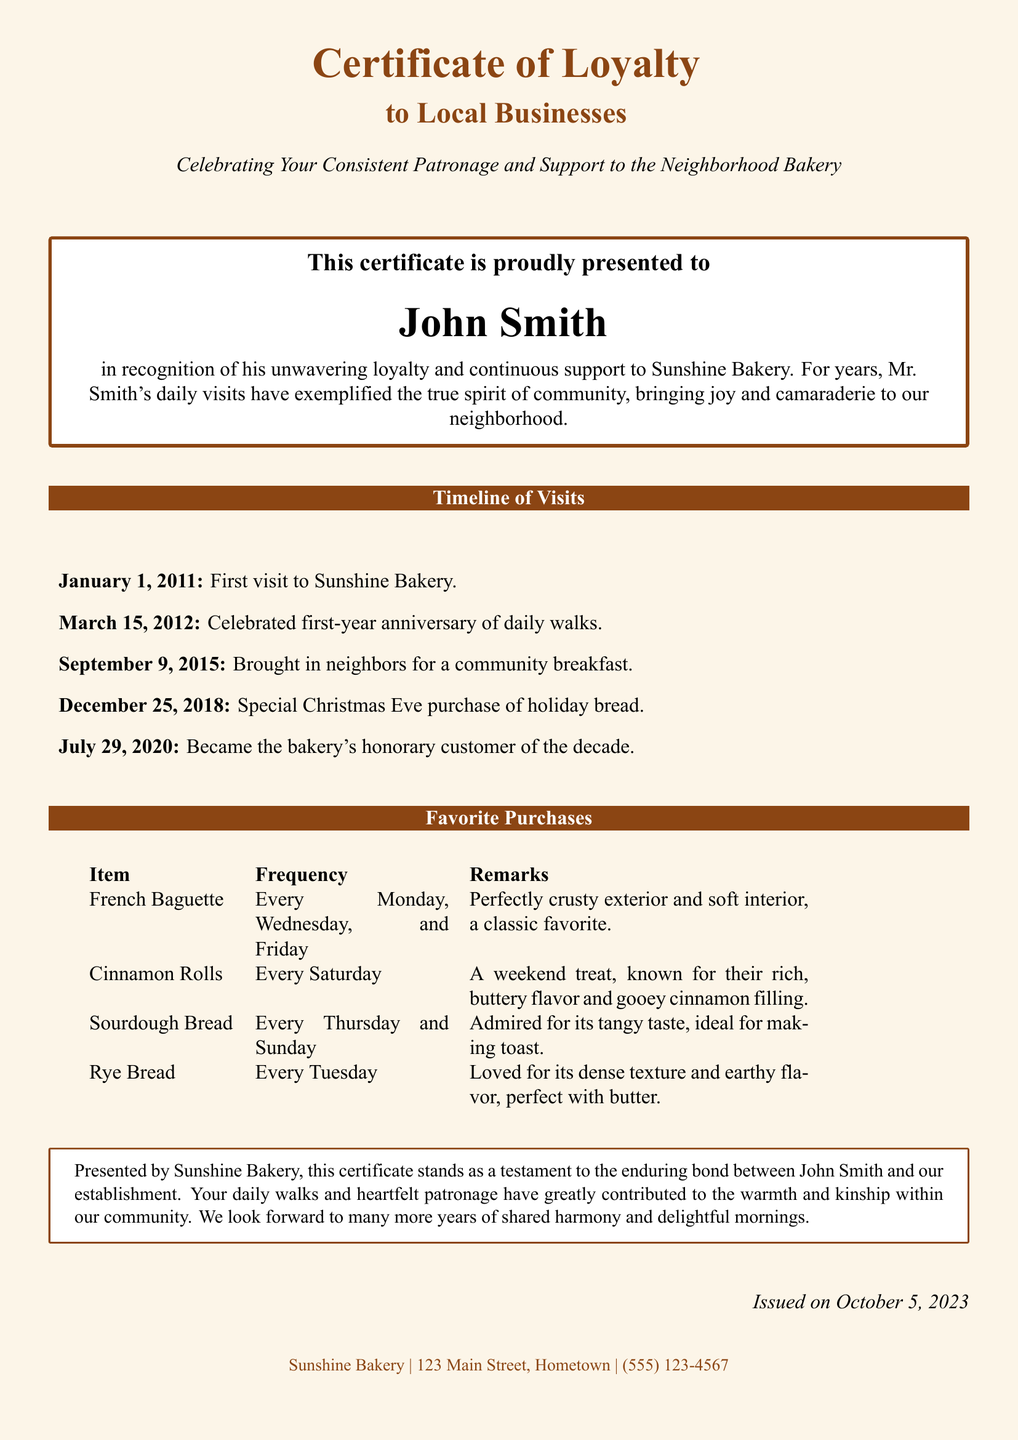What is the name of the person awarded the certificate? The name of the person awarded the certificate is stated prominently at the center of the document.
Answer: John Smith What is the name of the bakery? The bakery name is highlighted in the title of the certificate, which signifies its importance.
Answer: Sunshine Bakery When was the certificate issued? The issue date is mentioned at the bottom of the document in an italicized format.
Answer: October 5, 2023 How many favorite purchases are listed? The number of entries in the "Favorite Purchases" section indicates the available options.
Answer: Four What item is purchased every Tuesday? The "Favorite Purchases" section lists the items along with their purchase frequency.
Answer: Rye Bread What event was celebrated on March 15, 2012? The timeline outlines significant events alongside dates, allowing for easy reference.
Answer: First-year anniversary of daily walks Which purchase is a weekend treat? The document categorizes items with remarks that describe specific characteristics and occasions for buying.
Answer: Cinnamon Rolls What is the frequency of the French Baguette purchase? The frequency is stated clearly within the item description in the table format.
Answer: Every Monday, Wednesday, and Friday 